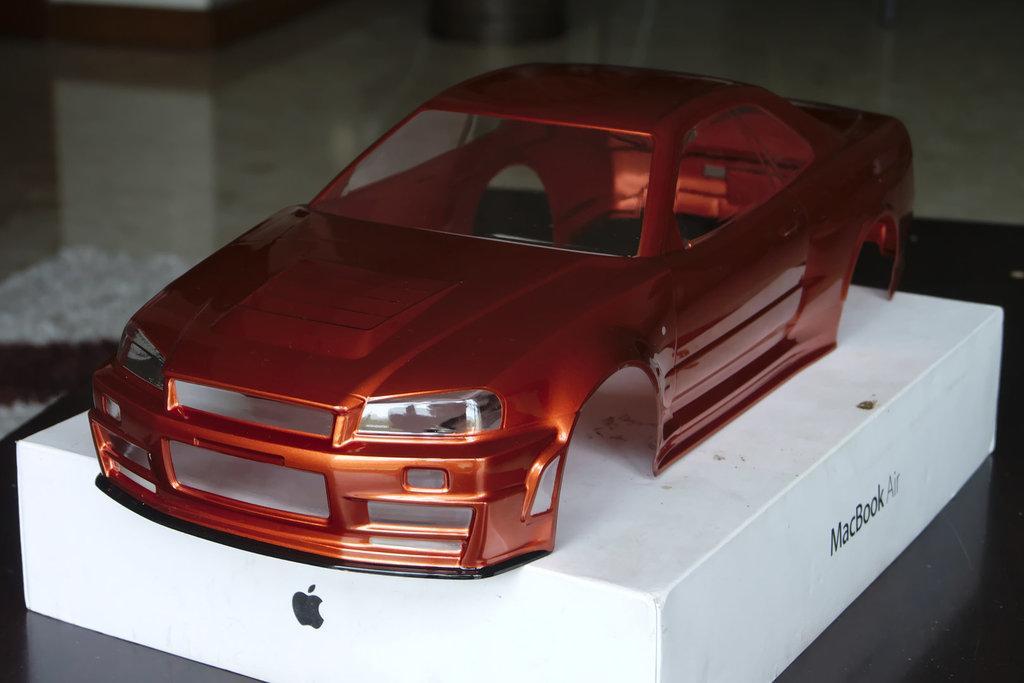Can you describe this image briefly? In this picture there is a toy car and which is on the box which is white in colour with some text written on it. In the background there are objects which are white in colour and there is a wall. 